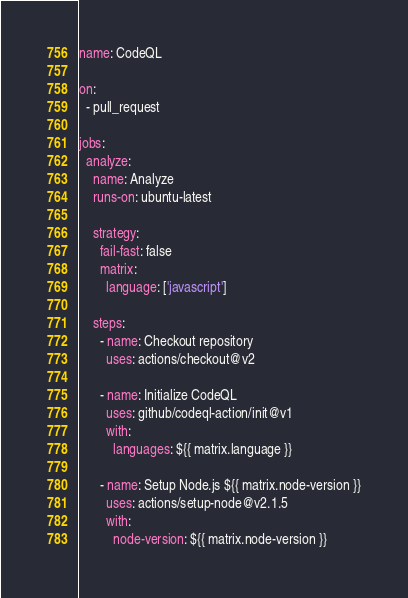<code> <loc_0><loc_0><loc_500><loc_500><_YAML_>name: CodeQL

on:
  - pull_request

jobs:
  analyze:
    name: Analyze
    runs-on: ubuntu-latest

    strategy:
      fail-fast: false
      matrix:
        language: ['javascript']

    steps:
      - name: Checkout repository
        uses: actions/checkout@v2

      - name: Initialize CodeQL
        uses: github/codeql-action/init@v1
        with:
          languages: ${{ matrix.language }}

      - name: Setup Node.js ${{ matrix.node-version }}
        uses: actions/setup-node@v2.1.5
        with:
          node-version: ${{ matrix.node-version }}
</code> 